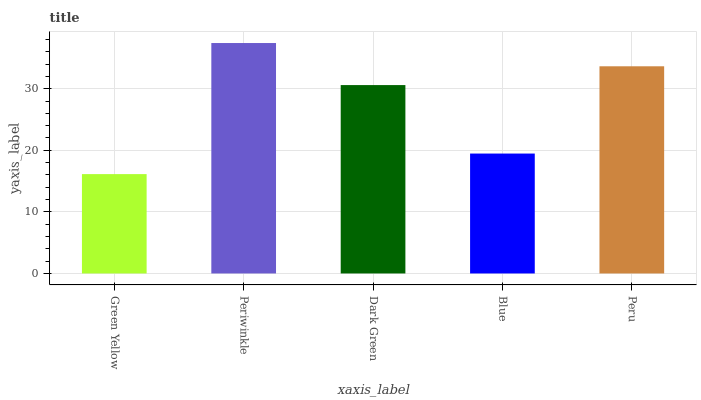Is Green Yellow the minimum?
Answer yes or no. Yes. Is Periwinkle the maximum?
Answer yes or no. Yes. Is Dark Green the minimum?
Answer yes or no. No. Is Dark Green the maximum?
Answer yes or no. No. Is Periwinkle greater than Dark Green?
Answer yes or no. Yes. Is Dark Green less than Periwinkle?
Answer yes or no. Yes. Is Dark Green greater than Periwinkle?
Answer yes or no. No. Is Periwinkle less than Dark Green?
Answer yes or no. No. Is Dark Green the high median?
Answer yes or no. Yes. Is Dark Green the low median?
Answer yes or no. Yes. Is Green Yellow the high median?
Answer yes or no. No. Is Green Yellow the low median?
Answer yes or no. No. 